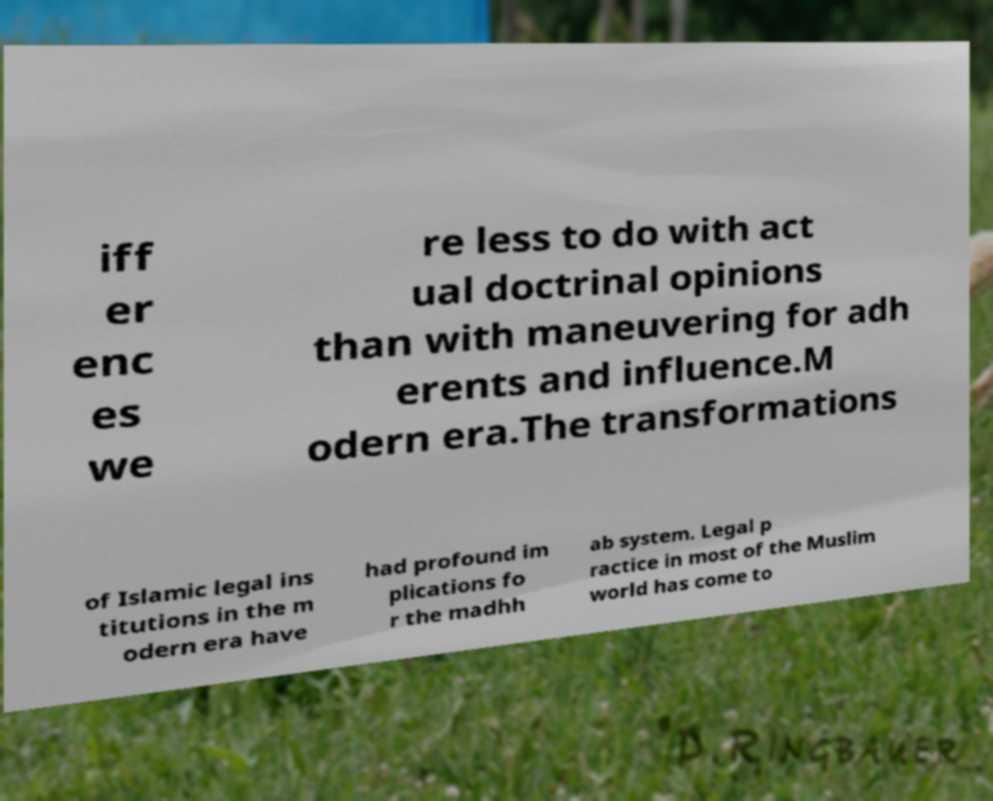Can you read and provide the text displayed in the image?This photo seems to have some interesting text. Can you extract and type it out for me? iff er enc es we re less to do with act ual doctrinal opinions than with maneuvering for adh erents and influence.M odern era.The transformations of Islamic legal ins titutions in the m odern era have had profound im plications fo r the madhh ab system. Legal p ractice in most of the Muslim world has come to 